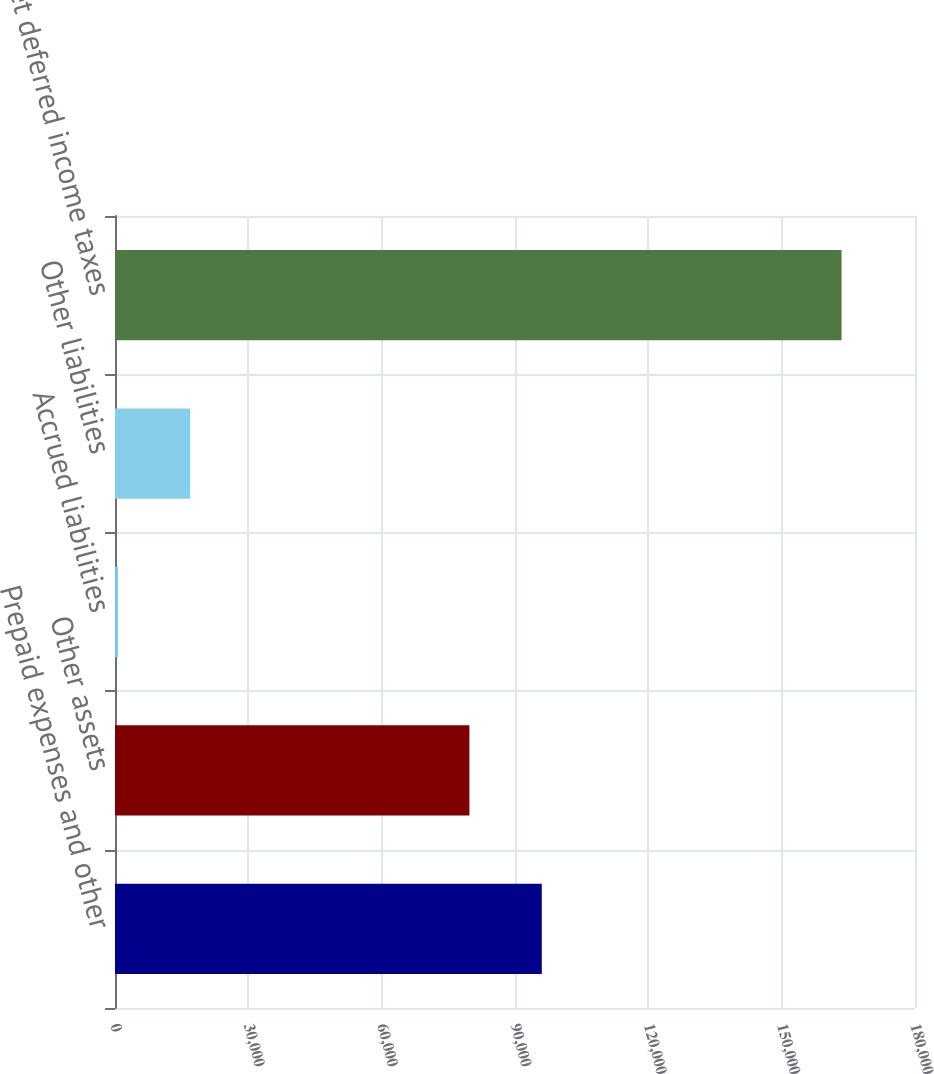<chart> <loc_0><loc_0><loc_500><loc_500><bar_chart><fcel>Prepaid expenses and other<fcel>Other assets<fcel>Accrued liabilities<fcel>Other liabilities<fcel>Net deferred income taxes<nl><fcel>96029.6<fcel>79746<fcel>641<fcel>16924.6<fcel>163477<nl></chart> 